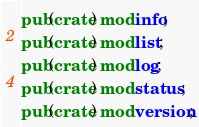<code> <loc_0><loc_0><loc_500><loc_500><_Rust_>pub(crate) mod info;
pub(crate) mod list;
pub(crate) mod log;
pub(crate) mod status;
pub(crate) mod version;
</code> 